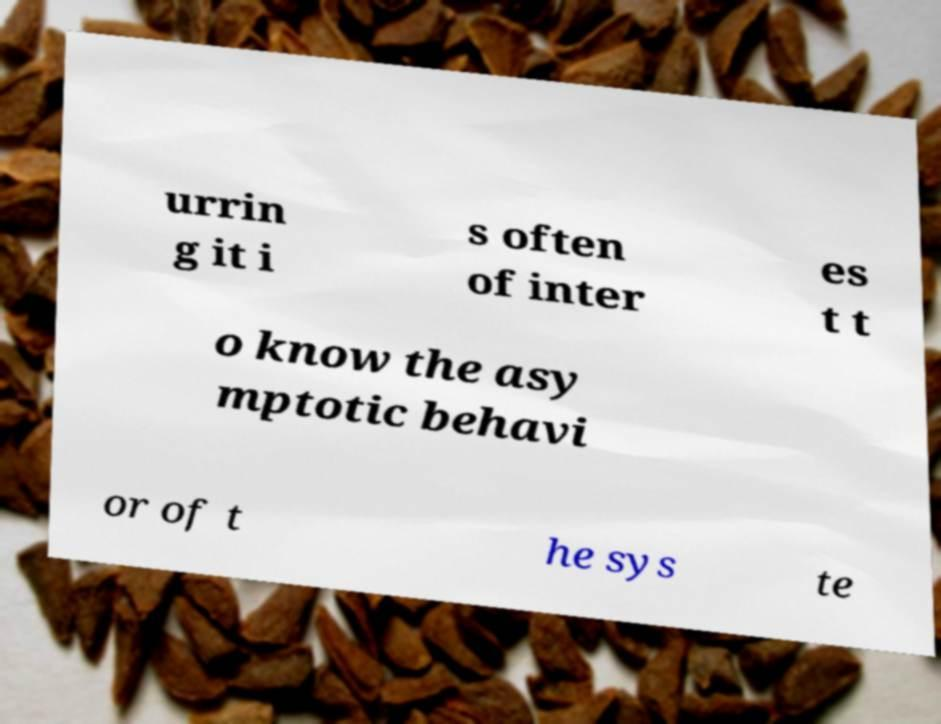Please identify and transcribe the text found in this image. urrin g it i s often of inter es t t o know the asy mptotic behavi or of t he sys te 